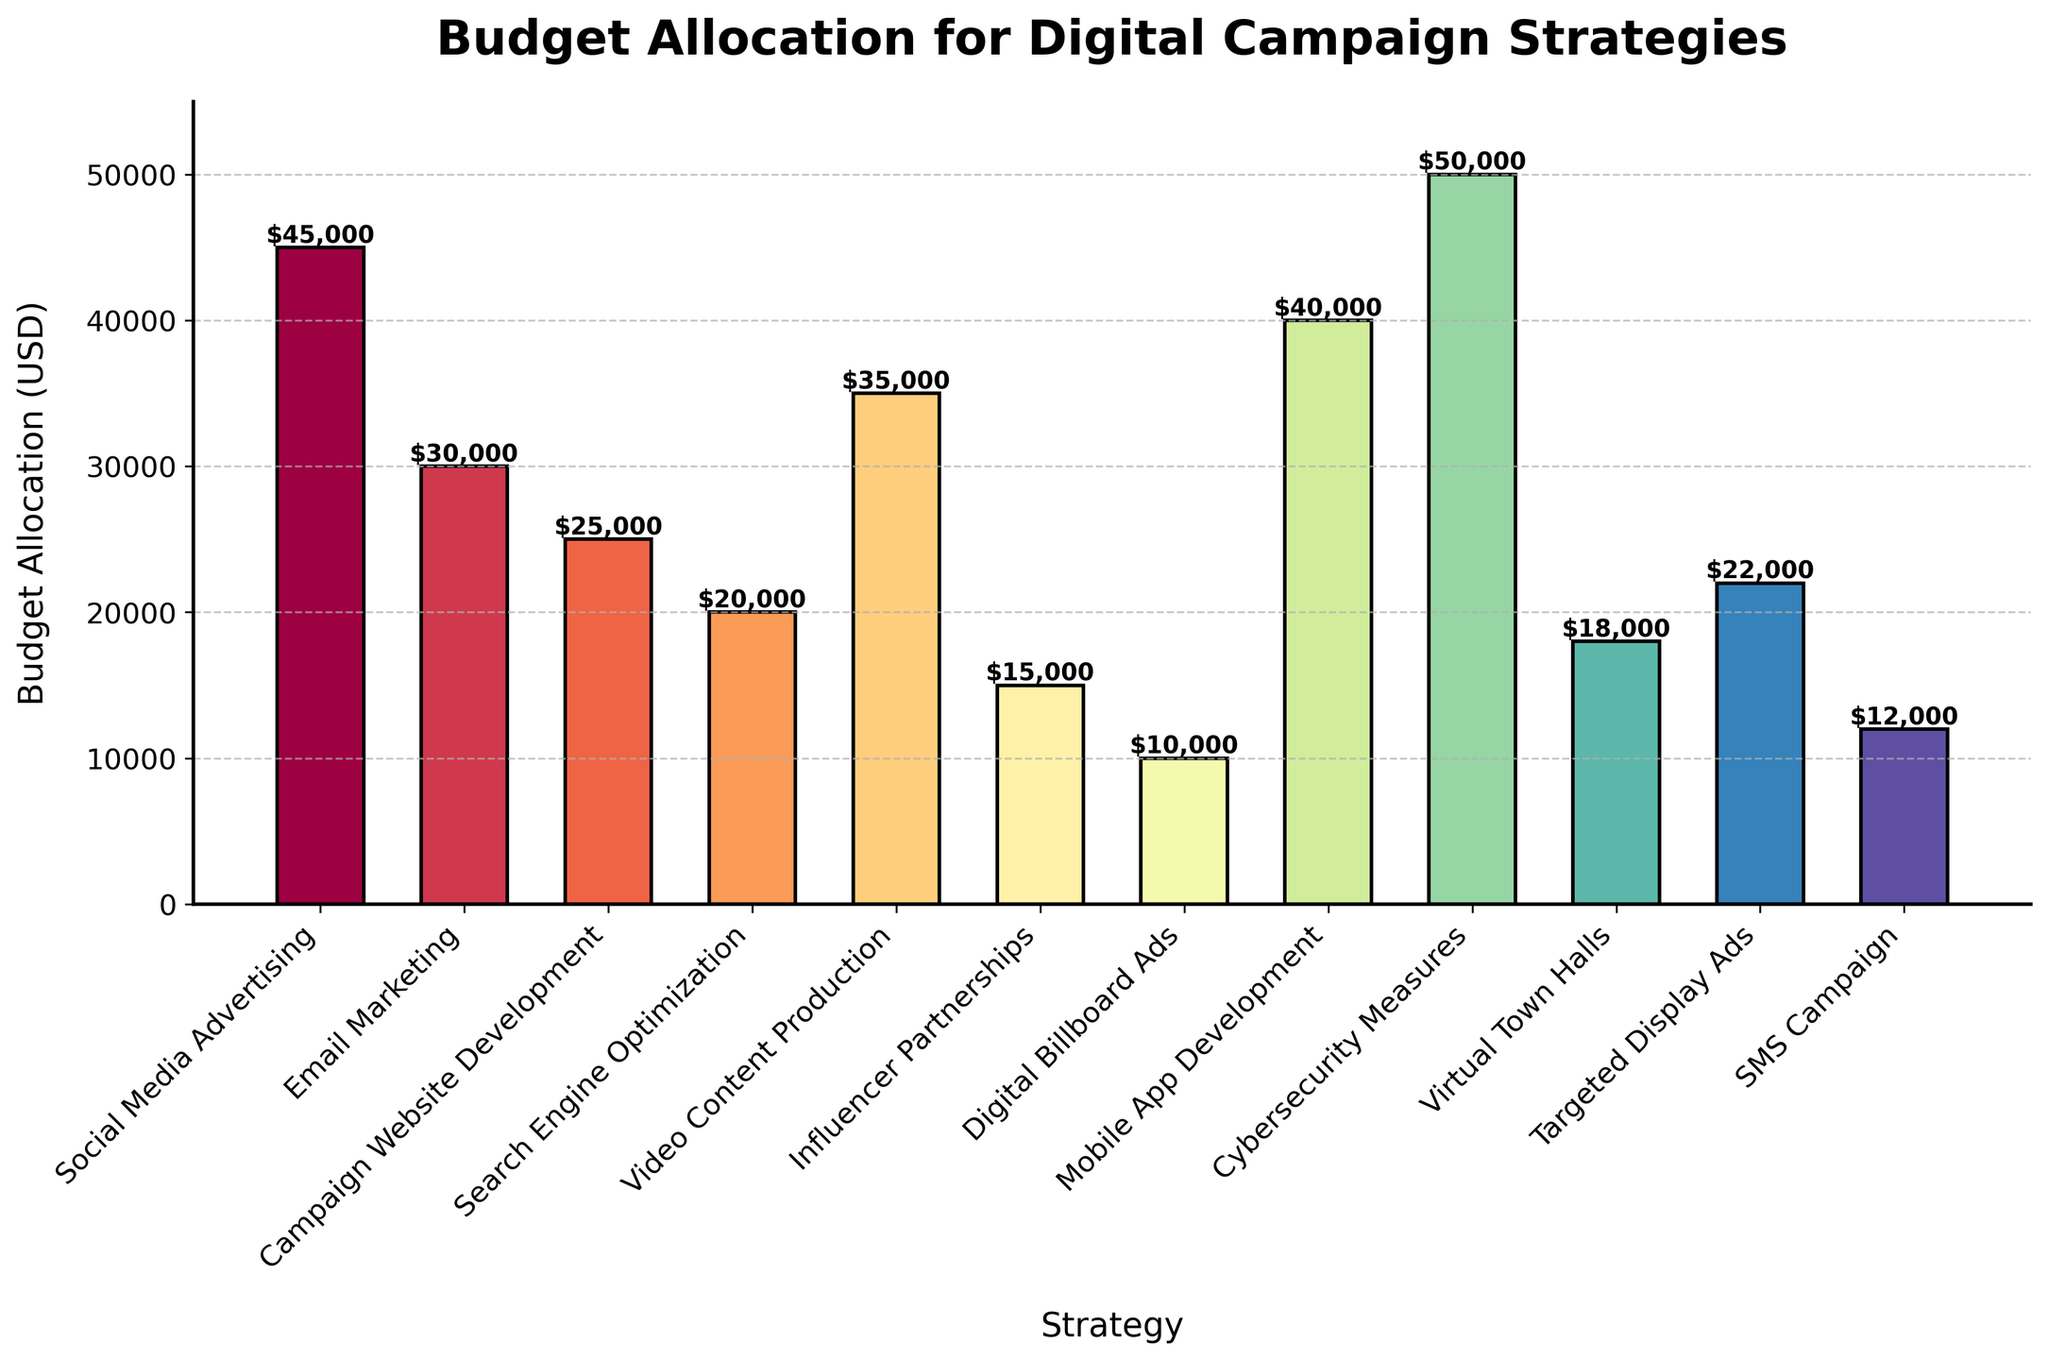What is the highest budget allocated to a single strategy? The highest budget allocation can be found by looking for the tallest bar in the chart. The title on top of the bar indicates the strategy it represents. The tallest bar corresponds to Cybersecurity Measures with a budget of $50,000.
Answer: $50,000 Which strategy received the lowest budget allocation? To find the lowest budget allocation, identify the shortest bar in the chart. The label indicating the strategy next to this bar points to Digital Billboard Ads, which has a budget of $10,000.
Answer: $10,000 How much more budget is allocated to Social Media Advertising compared to SMS Campaigns? Locate the bars for Social Media Advertising and SMS Campaigns in the chart. Note their heights and the dollar amounts on top, which are $45,000 and $12,000 respectively. Subtract the budget for SMS Campaigns from that for Social Media Advertising (45,000 - 12,000).
Answer: $33,000 What is the total budget allocation for Campaign Website Development and Virtual Town Halls combined? Find the bars for Campaign Website Development and Virtual Town Halls and note the dollar amounts on top, which are $25,000 and $18,000 respectively. Add these amounts together (25,000 + 18,000).
Answer: $43,000 Which strategy has a budget allocation closest to the median value? Sort all budget figures in ascending order: $10,000, $12,000, $15,000, $18,000, $20,000, $22,000, $25,000, $30,000, $35,000, $40,000, $45,000, $50,000. The median value among 12 items is the average of the 6th and 7th values: (22,000 + 25,000) / 2 = $23,500. The closest amount is $22,000 for Targeted Display Ads.
Answer: Targeted Display Ads How does the budget allocated to Email Marketing compare to that allocated for Search Engine Optimization? The budget for Email Marketing is $30,000 and for Search Engine Optimization is $20,000. Comparison shows that Email Marketing receives a larger budget.
Answer: Email Marketing What is the average budget allocation across all strategies? Sum the budget allocations for all strategies and divide by the number of strategies. The sum is $45,000 + $30,000 + $25,000 + $20,000 + $35,000 + $15,000 + $10,000 + $40,000 + $50,000 + $18,000 + $22,000 + $12,000 = $322,000. There are 12 strategies. Average = $322,000 / 12.
Answer: $26,833.33 What is the difference in budget allocation between Mobile App Development and Video Content Production? Identify the dollar amounts for Mobile App Development ($40,000) and Video Content Production ($35,000). Subtract the smaller value from the larger one (40,000 - 35,000).
Answer: $5,000 Which strategies have a budget allocation greater than $30,000? List the bars and their labels corresponding to budgets above $30,000: Social Media Advertising ($45,000), Email Marketing ($30,000), Video Content Production ($35,000), Mobile App Development ($40,000), Cybersecurity Measures ($50,000).
Answer: Social Media Advertising, Video Content Production, Mobile App Development, Cybersecurity Measures How many strategies have a budget allocation less than $20,000? Count the bars in the chart that represent budgets under $20,000: Influencer Partnerships ($15,000), Digital Billboard Ads ($10,000), Virtual Town Halls ($18,000), SMS Campaign ($12,000). There are 4 bars.
Answer: 4 